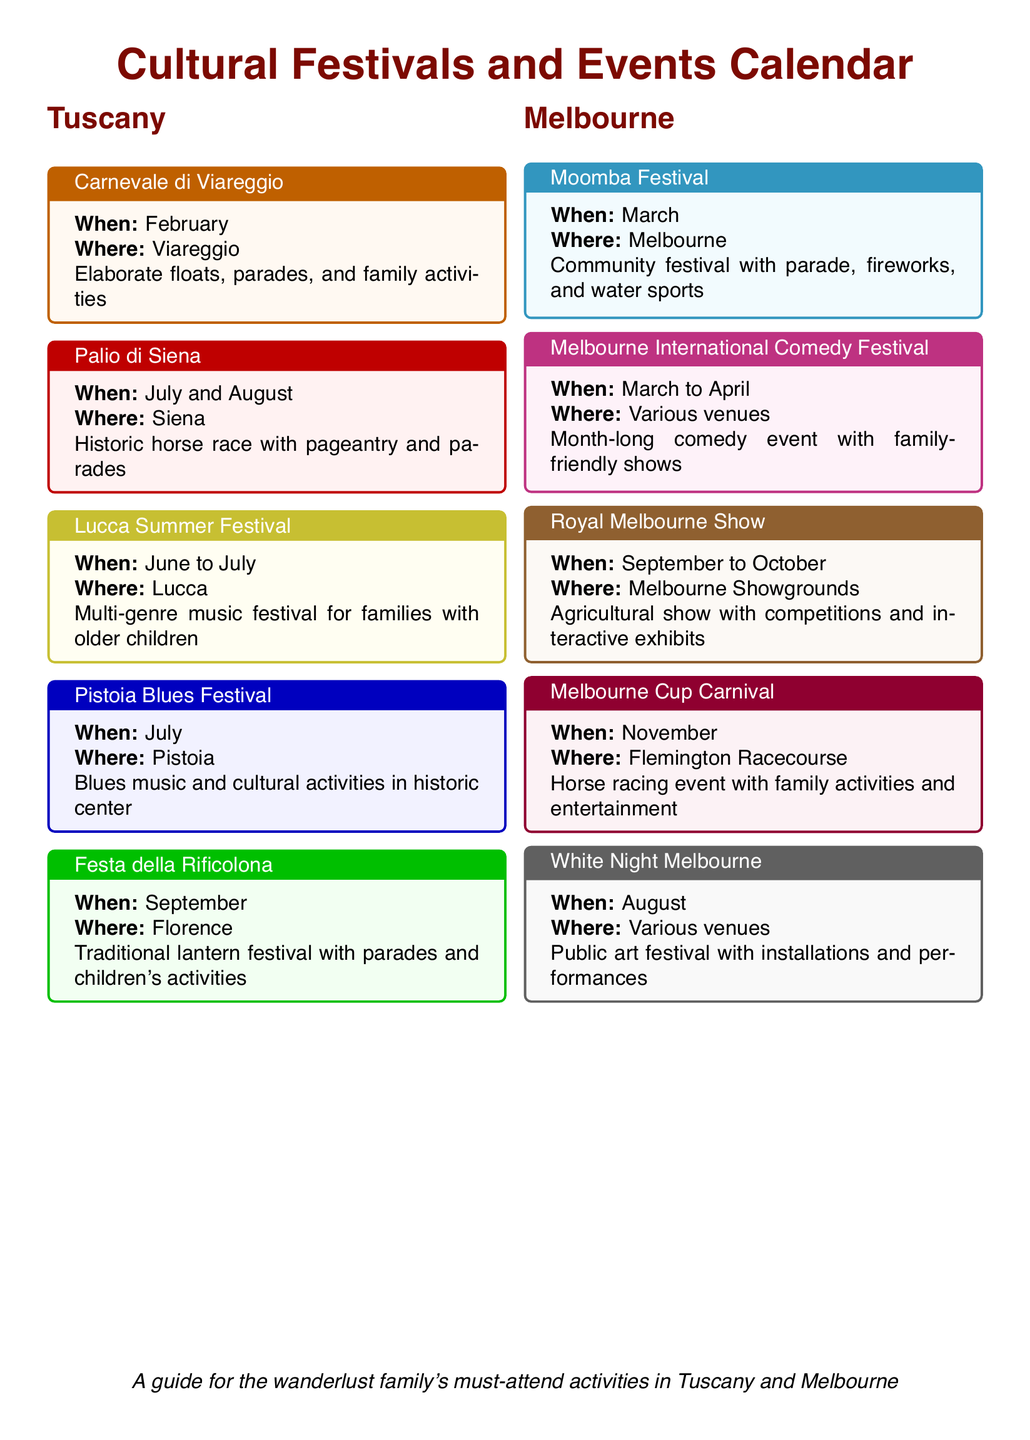What is the location of Carnevale di Viareggio? The document states that the Carnevale di Viareggio takes place in Viareggio.
Answer: Viareggio When does the Moomba Festival occur? The Moomba Festival is scheduled for March according to the document.
Answer: March What type of festival is the Royal Melbourne Show? The document describes it as an agricultural show.
Answer: Agricultural show Which event in Tuscany occurs in September? The Festa della Rificolona is listed as taking place in September in the document.
Answer: Festa della Rificolona How long does the Melbourne International Comedy Festival last? The document specifies that it lasts from March to April.
Answer: March to April What is the main theme of the White Night Melbourne? The document describes it as a public art festival.
Answer: Public art festival Which city hosts the Palio di Siena? According to the document, the Palio di Siena is hosted in Siena.
Answer: Siena What significant activity does the Moomba Festival include? The document mentions that it features a parade.
Answer: Parade 